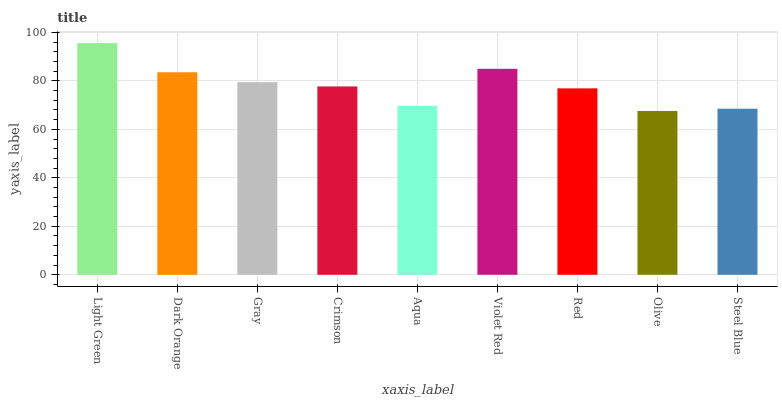Is Olive the minimum?
Answer yes or no. Yes. Is Light Green the maximum?
Answer yes or no. Yes. Is Dark Orange the minimum?
Answer yes or no. No. Is Dark Orange the maximum?
Answer yes or no. No. Is Light Green greater than Dark Orange?
Answer yes or no. Yes. Is Dark Orange less than Light Green?
Answer yes or no. Yes. Is Dark Orange greater than Light Green?
Answer yes or no. No. Is Light Green less than Dark Orange?
Answer yes or no. No. Is Crimson the high median?
Answer yes or no. Yes. Is Crimson the low median?
Answer yes or no. Yes. Is Aqua the high median?
Answer yes or no. No. Is Red the low median?
Answer yes or no. No. 